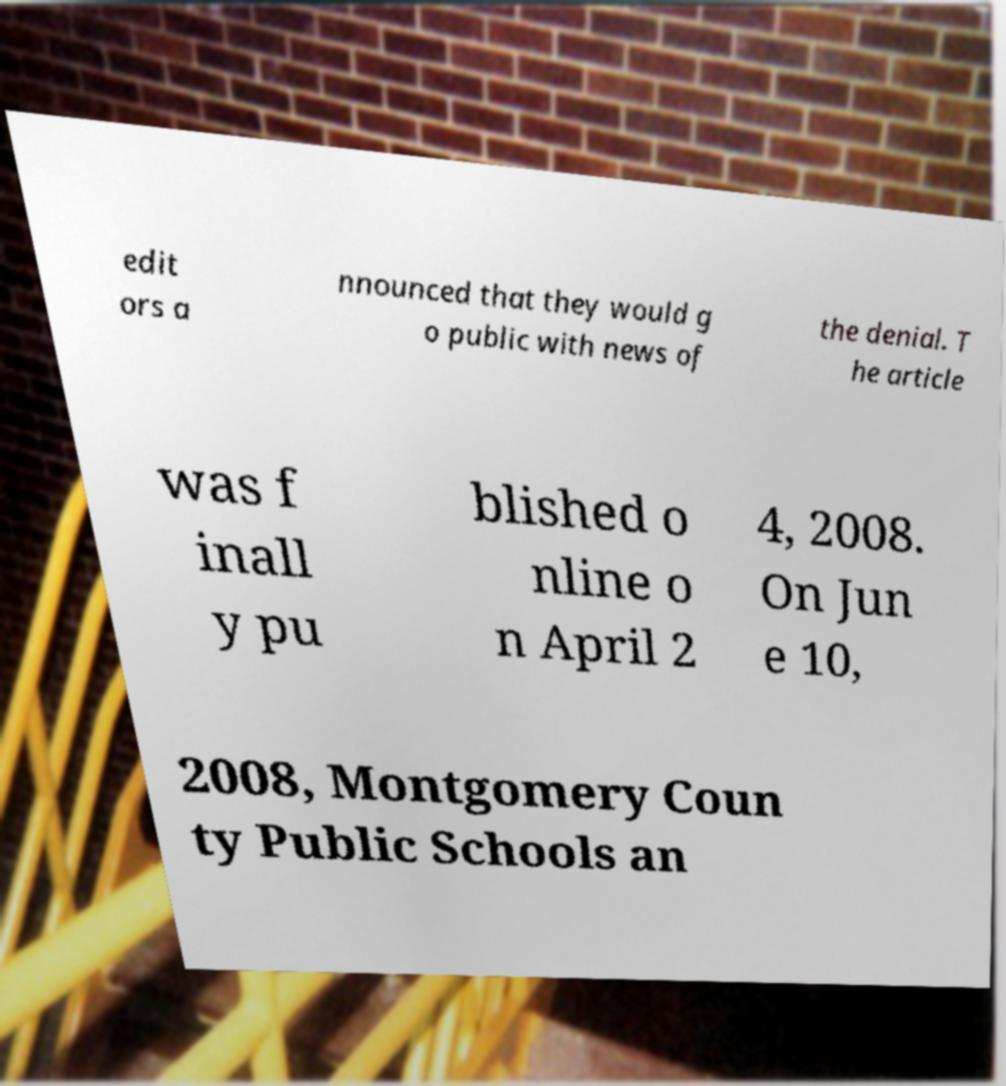I need the written content from this picture converted into text. Can you do that? edit ors a nnounced that they would g o public with news of the denial. T he article was f inall y pu blished o nline o n April 2 4, 2008. On Jun e 10, 2008, Montgomery Coun ty Public Schools an 